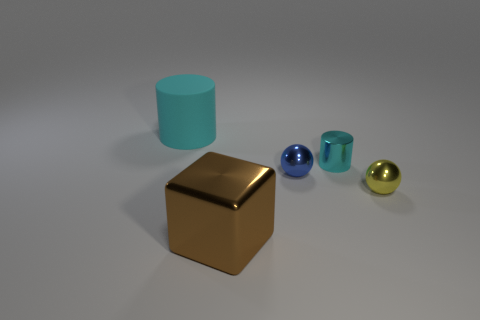Add 5 big green shiny cubes. How many objects exist? 10 Subtract all spheres. How many objects are left? 3 Add 2 small balls. How many small balls exist? 4 Subtract 1 yellow spheres. How many objects are left? 4 Subtract all blue balls. Subtract all cyan things. How many objects are left? 2 Add 1 metallic cylinders. How many metallic cylinders are left? 2 